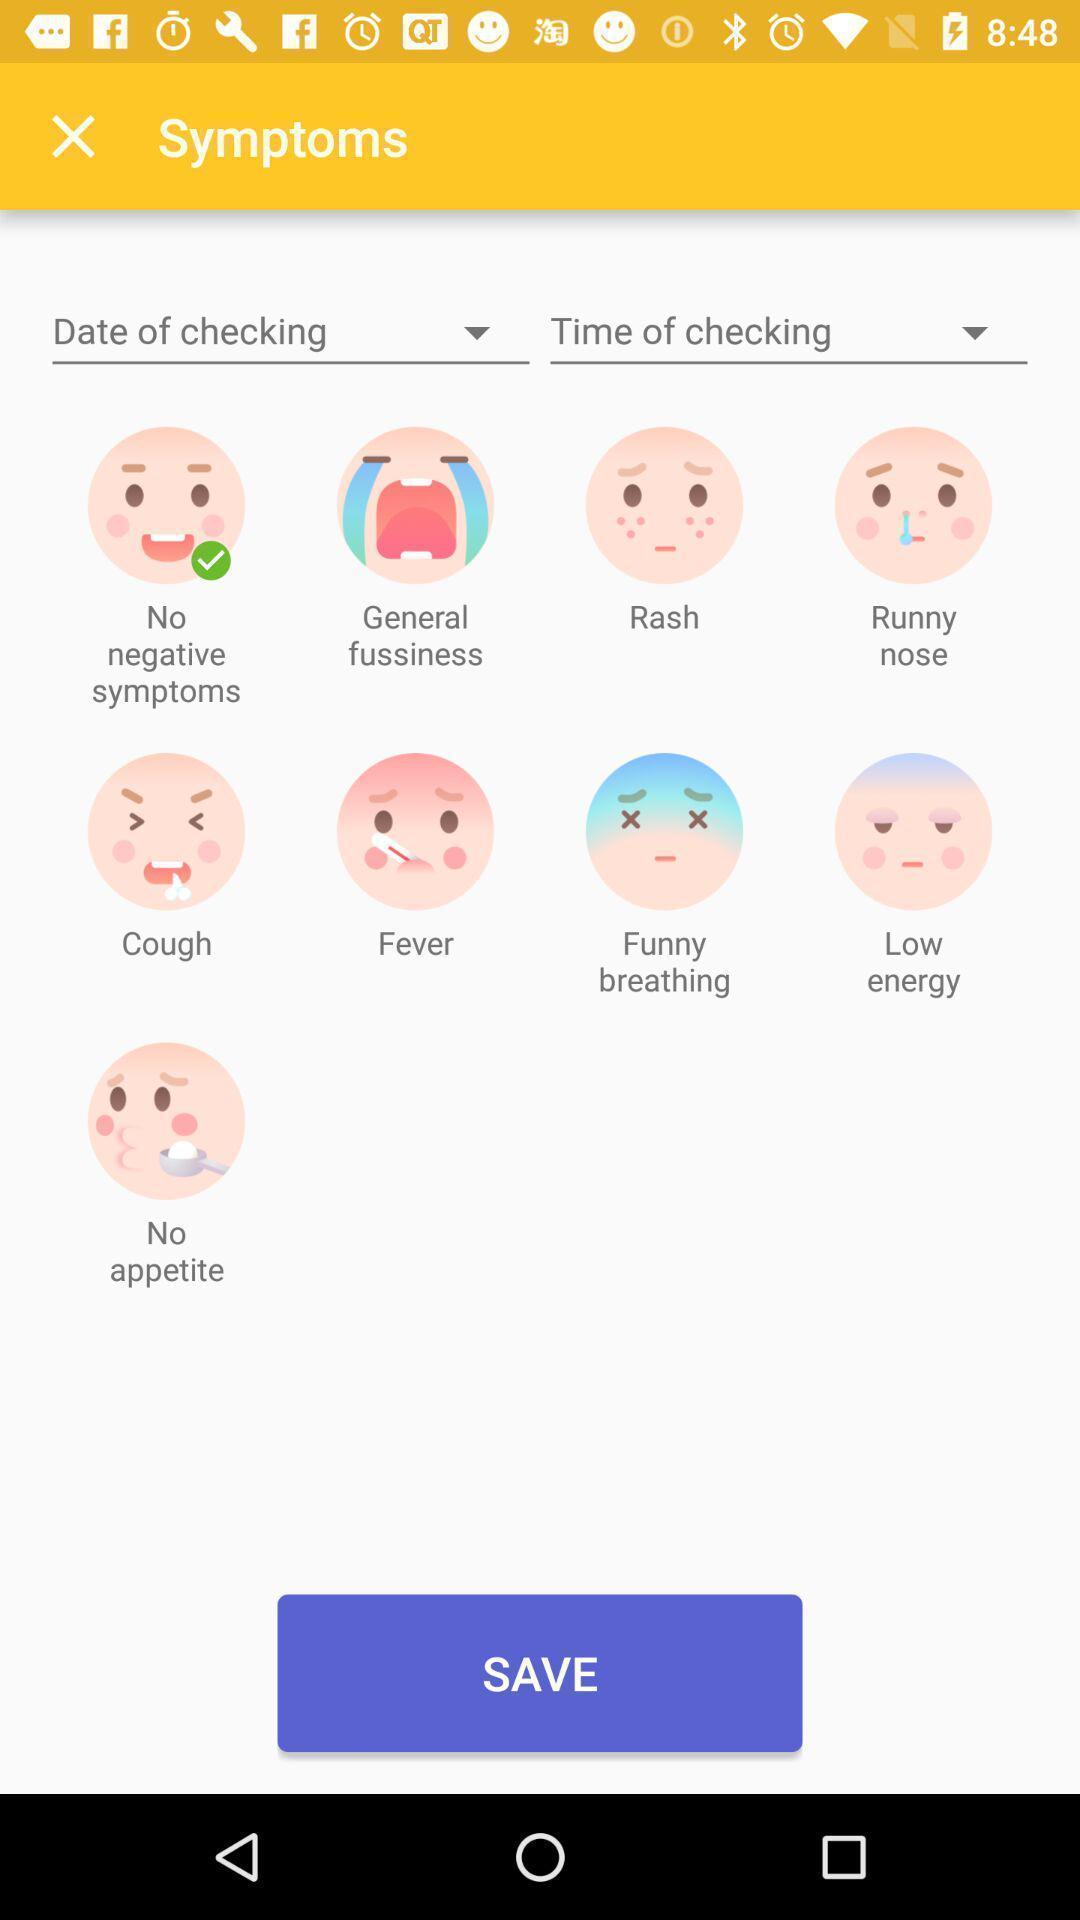Explain what's happening in this screen capture. Page showing list of symptoms in a healthcare app. 